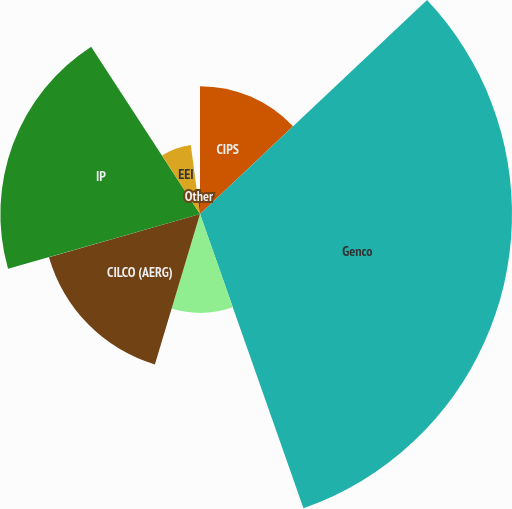<chart> <loc_0><loc_0><loc_500><loc_500><pie_chart><fcel>CIPS<fcel>Genco<fcel>CILCO (Illinois Regulated)<fcel>CILCO (AERG)<fcel>IP<fcel>EEI<fcel>Other<nl><fcel>12.97%<fcel>31.65%<fcel>10.02%<fcel>15.93%<fcel>20.25%<fcel>7.07%<fcel>2.11%<nl></chart> 